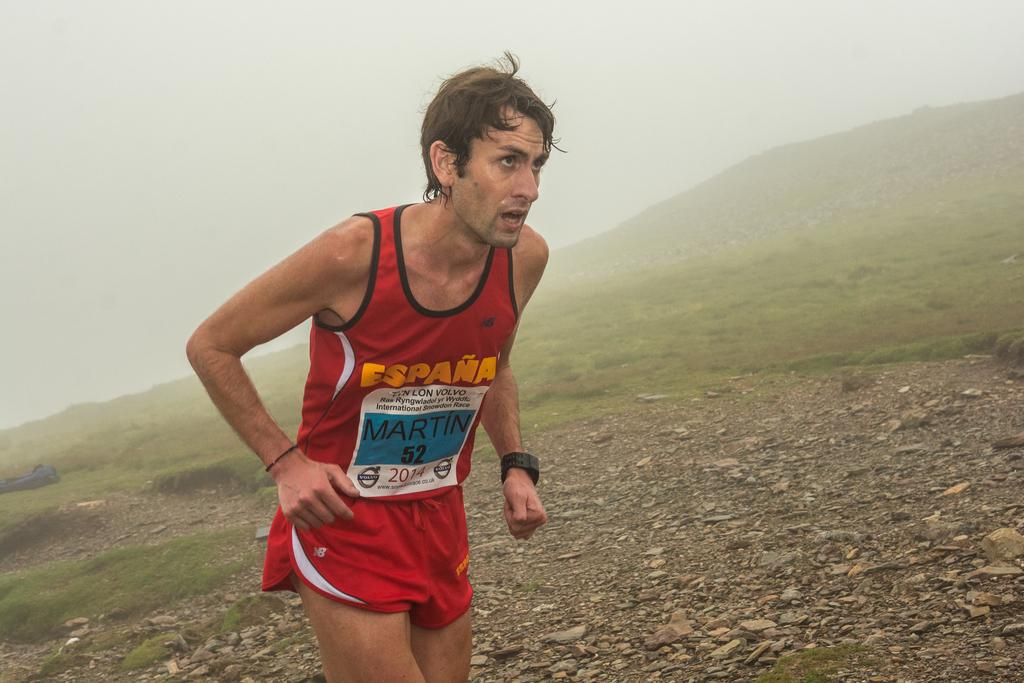Provide a one-sentence caption for the provided image. A RUNNER ON A GRAVEL HILL WEARING RED TANK TOP AND SHORTS NAMED MARTIN. 